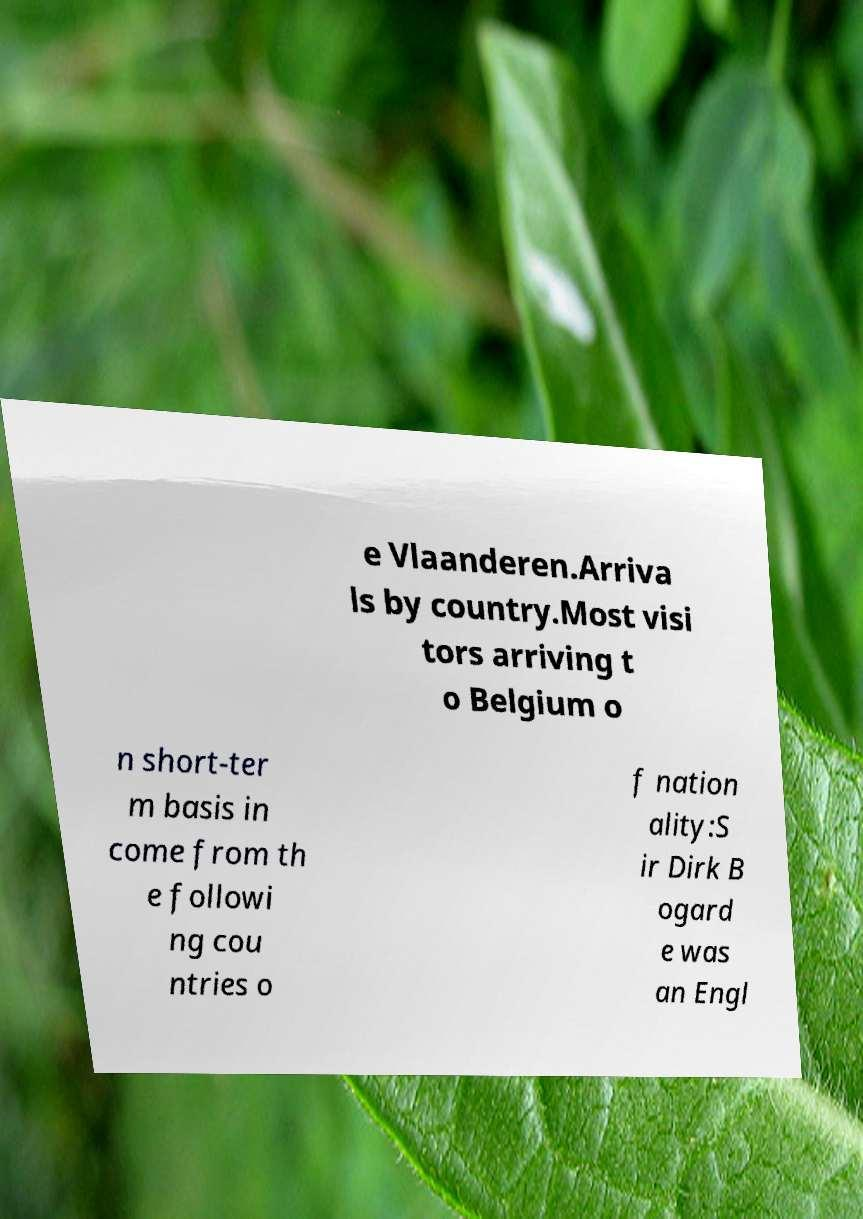What messages or text are displayed in this image? I need them in a readable, typed format. e Vlaanderen.Arriva ls by country.Most visi tors arriving t o Belgium o n short-ter m basis in come from th e followi ng cou ntries o f nation ality:S ir Dirk B ogard e was an Engl 